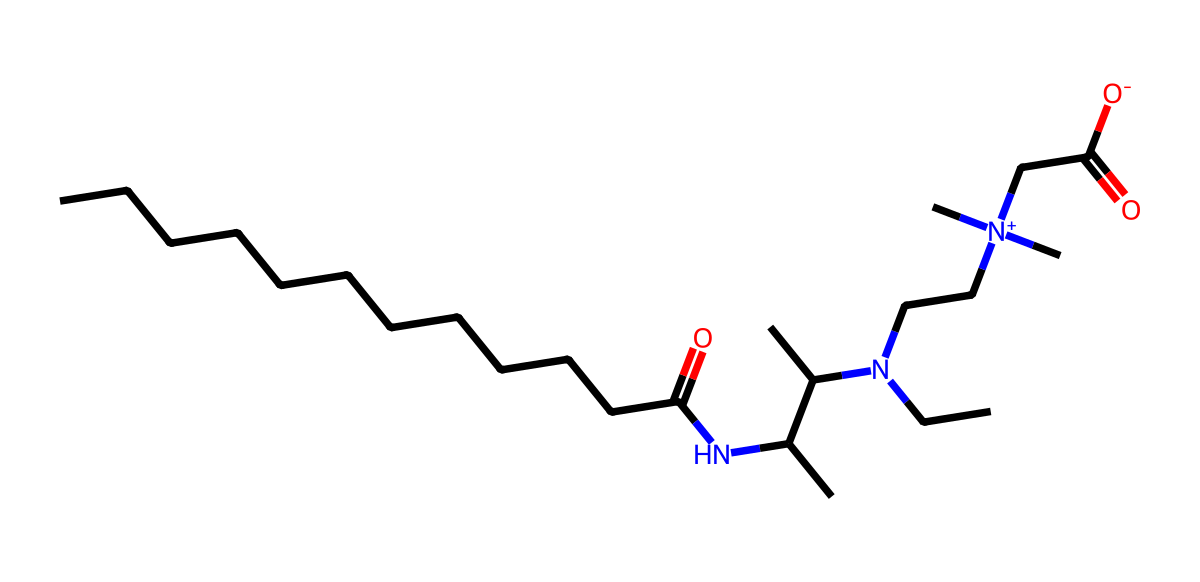What is the main functional group present in cocamidopropyl betaine? The chemical structure shows an amine group (-NH) and a carboxylic acid group (-COOH), which indicates that the compound is zwitterionic in nature. This combination is characteristic of amphoteric surfactants.
Answer: zwitterionic How many carbon atoms are present in cocamidopropyl betaine? By analyzing the SMILES representation, we count 20 carbon atoms in total. Each chain and branch contributes to the total count.
Answer: 20 What type of surfactant is cocamidopropyl betaine? The presence of both hydrophobic long carbon chains and a hydrophilic head group indicates that it acts as an amphoteric surfactant. Thus, it can function as both a cationic and anionic surfactant depending on the pH.
Answer: amphoteric Which part of the chemical structure contributes to the reduction of skin irritation? The polar head groups, particularly the amine and carboxylic acid functionalities, interact with water molecules, forming micelles that help in solubilizing dirt and oil while minimizing irritation by maintaining skin compatibility.
Answer: polar head groups What is the charge status of cocamidopropyl betaine at physiological pH? At physiological pH, the carboxylic acid group is typically deprotonated (-COO-), and the amine group is protonated, making the overall molecule zwitterionic, with both positive and negative charges present.
Answer: zwitterionic 